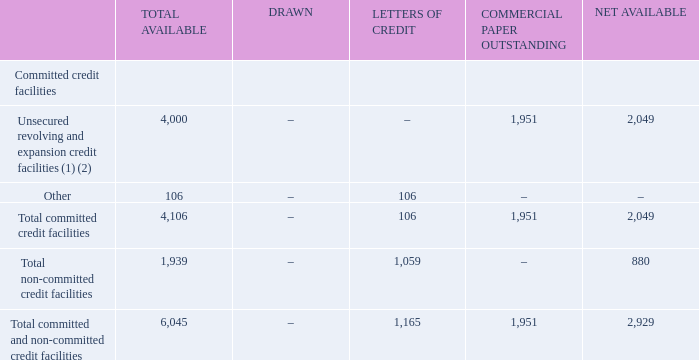CREDIT FACILITIES
Bell Canada may issue notes under its Canadian and U.S. commercial paper programs up to the maximum aggregate principal amount of $3 billion in either Canadian or U.S. currency provided that at no time shall such maximum amount of notes exceed $4 billion in Canadian currency which equals the aggregate amount available under Bell Canada’s committed supporting revolving and expansion credit facilities as at December 31, 2019. The total amount of the net available committed revolving and expansion credit facilities may be drawn at any time.
The table below is a summary of our total bank credit facilities at December 31, 2019.
(1) Bell Canada’s $2.5 billion and additional $500 million committed revolving credit facilities expire in November 2024 and November 2020, respectively, and its $1 billion committed expansion credit facility expires in November 2022. Bell Canada has the option, subject to certain conditions, to convert advances outstanding under the additional $500 million revolving credit facility into a term loan with a maximum one-year term.
(2) As of December 31, 2019, Bell Canada’s outstanding commercial paper included $1,502 million in U.S. dollars ($1,951 million in Canadian dollars). All of Bell Canada’s commercial paper outstanding is included in debt due within one year.
What is Bell Canada's outstanding commercial paper in 2019? $1,502 million in u.s. dollars ($1,951 million in canadian dollars). What is the net available amount for the total committed and non-committed credit facilities? 2,929. When do the revolving credit facilities expire? November 2024, november 2020. How many segments of committed credit facilities are there? Unsecured revolving and expansion credit facilities##Other
Answer: 2. What is the ratio of the net available total committed credit facilities over the net available total non-committed credit facilities? 2,049/880
Answer: 2.33. What percentage of the total non-committed credit facilities available is classified as net available? 
Answer scale should be: percent. 880/1,939
Answer: 45.38. 